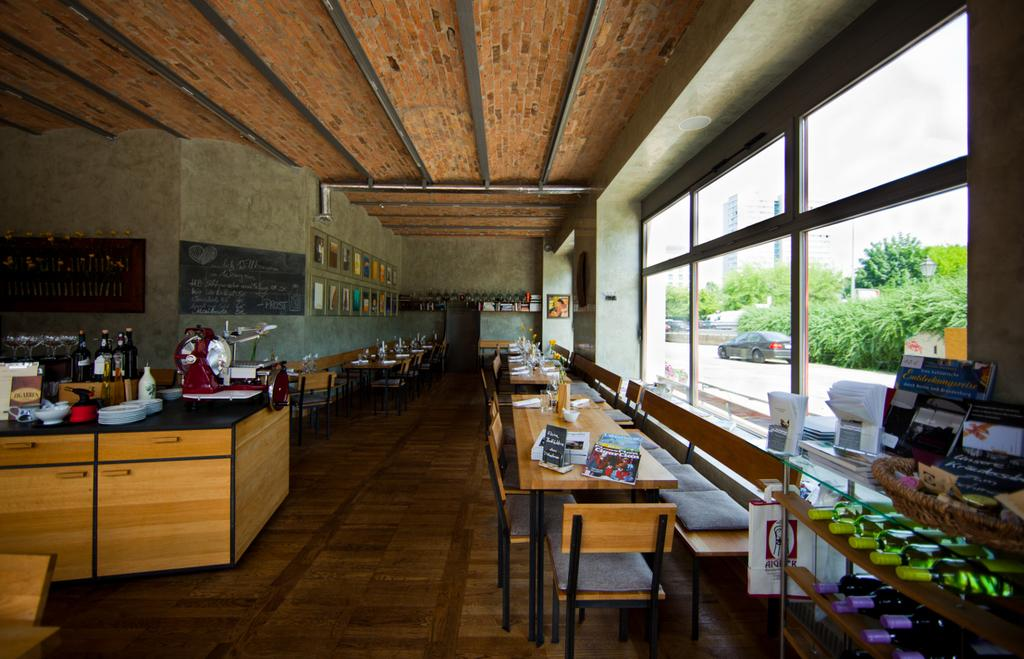What type of furniture is depicted in the image? There is a kitchen set in the image, which includes a table and chairs. What type of beverages are present in the image? There are wine bottles in the image. Where are the books located in the image? There are no books present in the image. What type of alley can be seen in the image? There is no alley present in the image. 